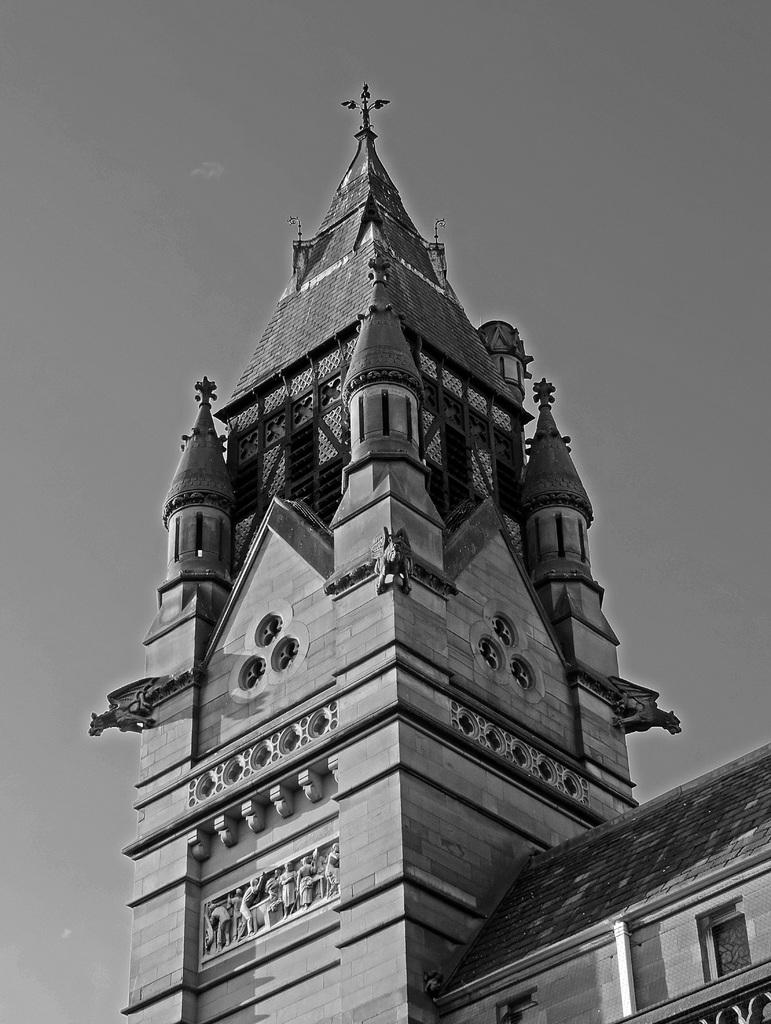What is the color scheme of the image? The image is black and white. What type of structure can be seen in the image? There is a building in the image. What feature of the building is visible? There are windows visible in the image. What else is present in the image besides the building? There is a pole in the image. What part of the natural environment can be seen in the image? The sky is visible in the image. What type of root can be seen growing near the building in the image? There is no root visible in the image; it is a black and white image with a building, windows, a pole, and the sky. 